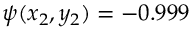<formula> <loc_0><loc_0><loc_500><loc_500>\psi ( x _ { 2 } , y _ { 2 } ) = - 0 . 9 9 9</formula> 